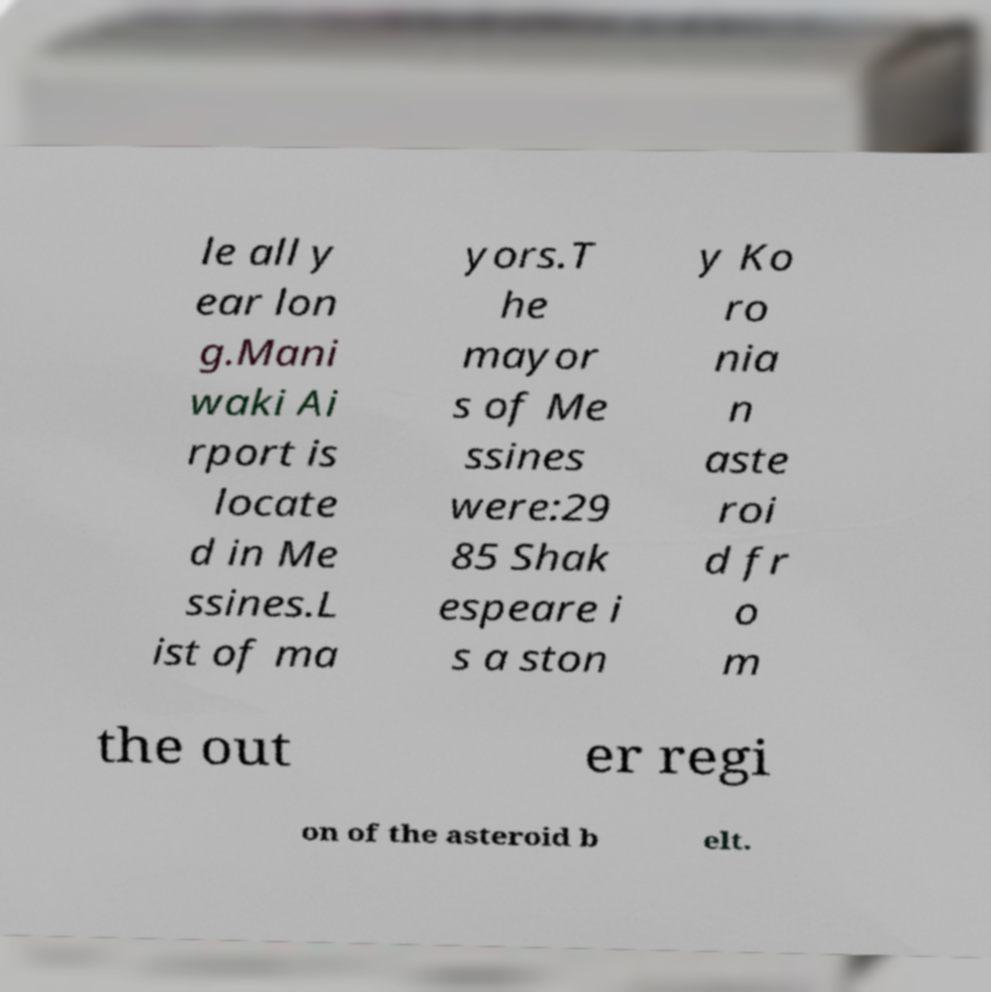Please read and relay the text visible in this image. What does it say? le all y ear lon g.Mani waki Ai rport is locate d in Me ssines.L ist of ma yors.T he mayor s of Me ssines were:29 85 Shak espeare i s a ston y Ko ro nia n aste roi d fr o m the out er regi on of the asteroid b elt. 